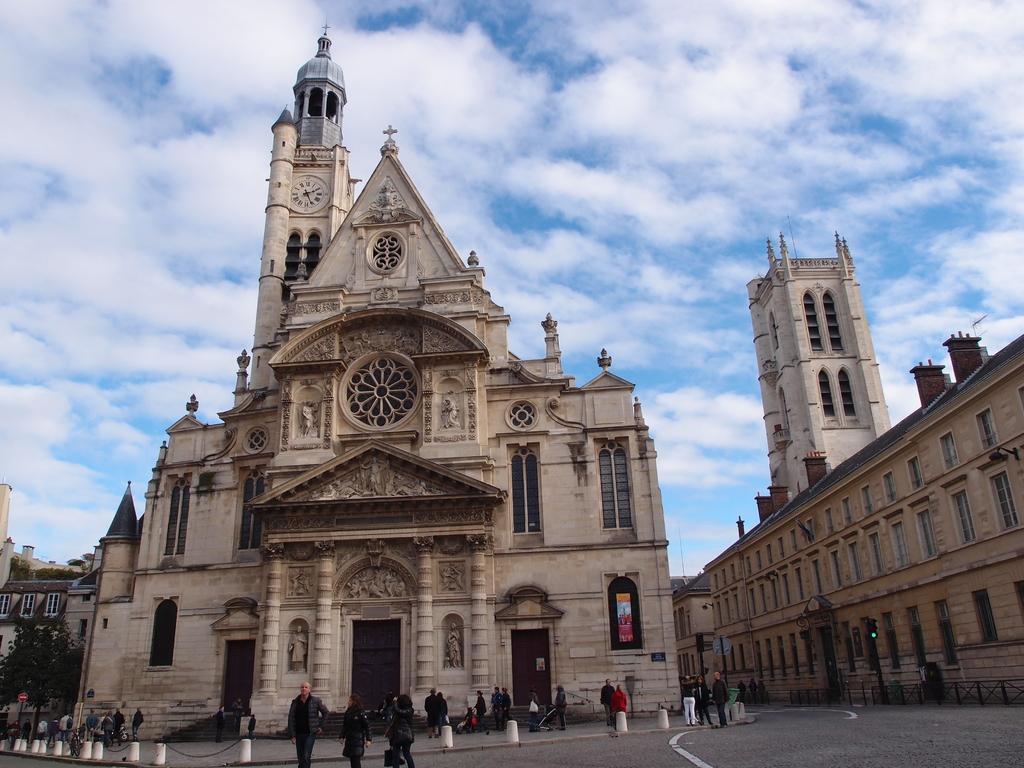Describe this image in one or two sentences. In the image we can see there are buildings and these are the windows of the buildings. This is a road, tree and a cloudy sky. We can see there are even people walking and they are wearing clothes. 